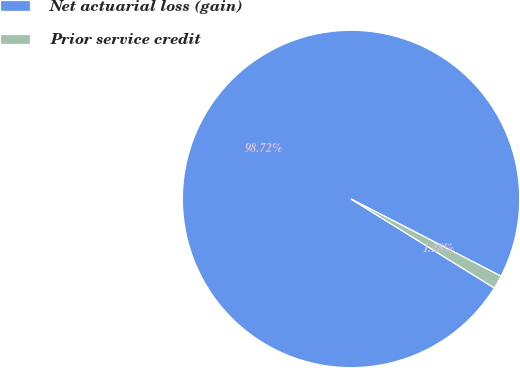<chart> <loc_0><loc_0><loc_500><loc_500><pie_chart><fcel>Net actuarial loss (gain)<fcel>Prior service credit<nl><fcel>98.72%<fcel>1.28%<nl></chart> 